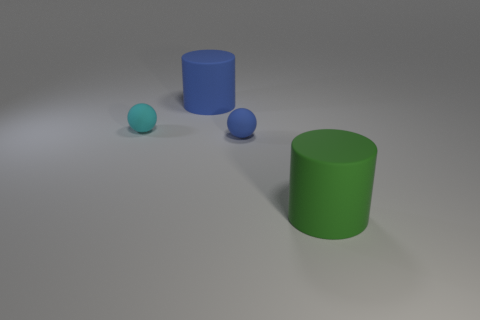There is a large rubber thing left of the large green rubber thing; is its shape the same as the tiny thing that is right of the tiny cyan object?
Provide a succinct answer. No. How many things are blue balls or tiny blue rubber cylinders?
Provide a short and direct response. 1. What size is the blue rubber object that is the same shape as the small cyan rubber object?
Your response must be concise. Small. Are there more big green rubber cylinders that are right of the tiny blue matte ball than tiny blue rubber things?
Provide a succinct answer. No. Is the green cylinder made of the same material as the blue cylinder?
Provide a short and direct response. Yes. What number of objects are either matte balls that are left of the tiny blue object or big rubber objects right of the big blue cylinder?
Ensure brevity in your answer.  2. What is the color of the other tiny object that is the same shape as the tiny cyan rubber object?
Your answer should be very brief. Blue. What number of objects are either matte things right of the cyan ball or red rubber objects?
Provide a succinct answer. 3. There is a tiny rubber thing behind the small blue sphere that is in front of the small object on the left side of the large blue rubber cylinder; what color is it?
Offer a very short reply. Cyan. There is another big thing that is the same material as the big green thing; what color is it?
Your answer should be compact. Blue. 